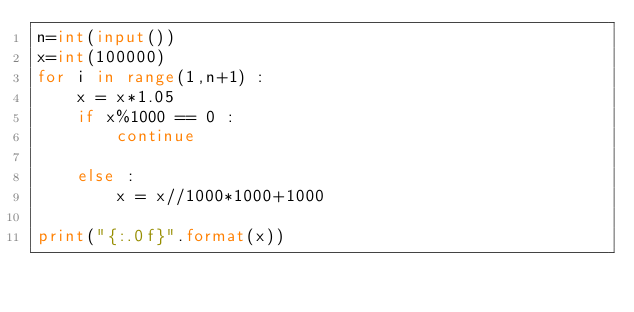<code> <loc_0><loc_0><loc_500><loc_500><_Python_>n=int(input())
x=int(100000)
for i in range(1,n+1) :
    x = x*1.05
    if x%1000 == 0 :
        continue
    
    else :
        x = x//1000*1000+1000
        
print("{:.0f}".format(x))
        
</code> 